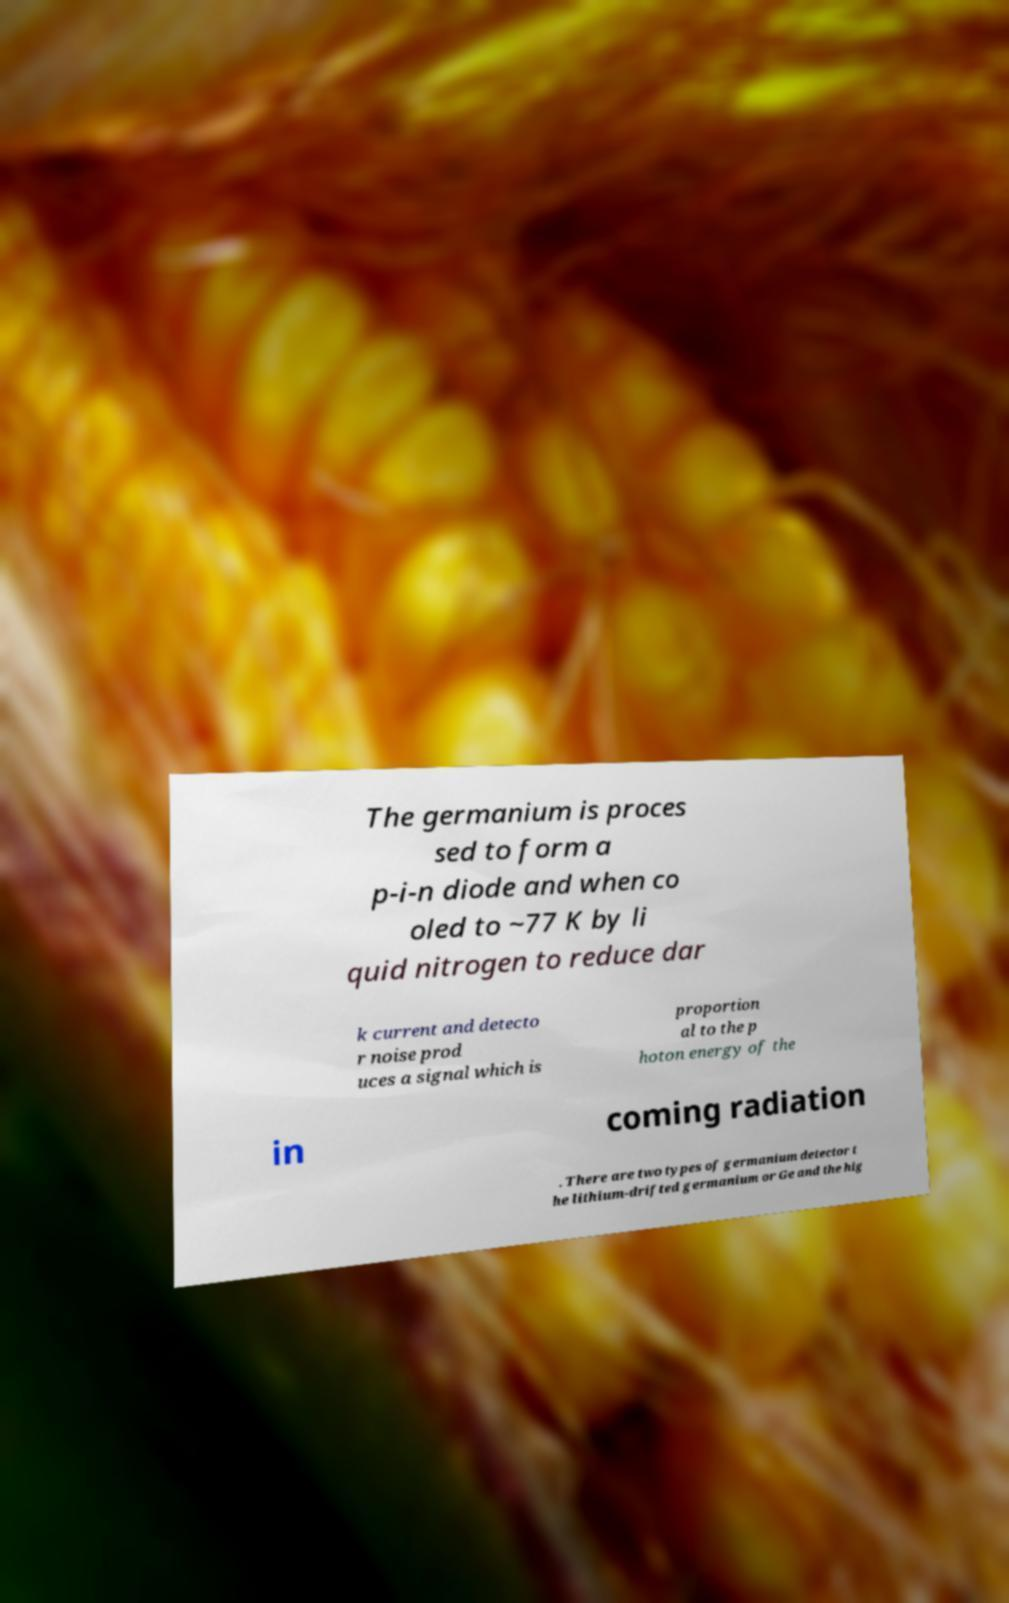Can you read and provide the text displayed in the image?This photo seems to have some interesting text. Can you extract and type it out for me? The germanium is proces sed to form a p-i-n diode and when co oled to ~77 K by li quid nitrogen to reduce dar k current and detecto r noise prod uces a signal which is proportion al to the p hoton energy of the in coming radiation . There are two types of germanium detector t he lithium-drifted germanium or Ge and the hig 